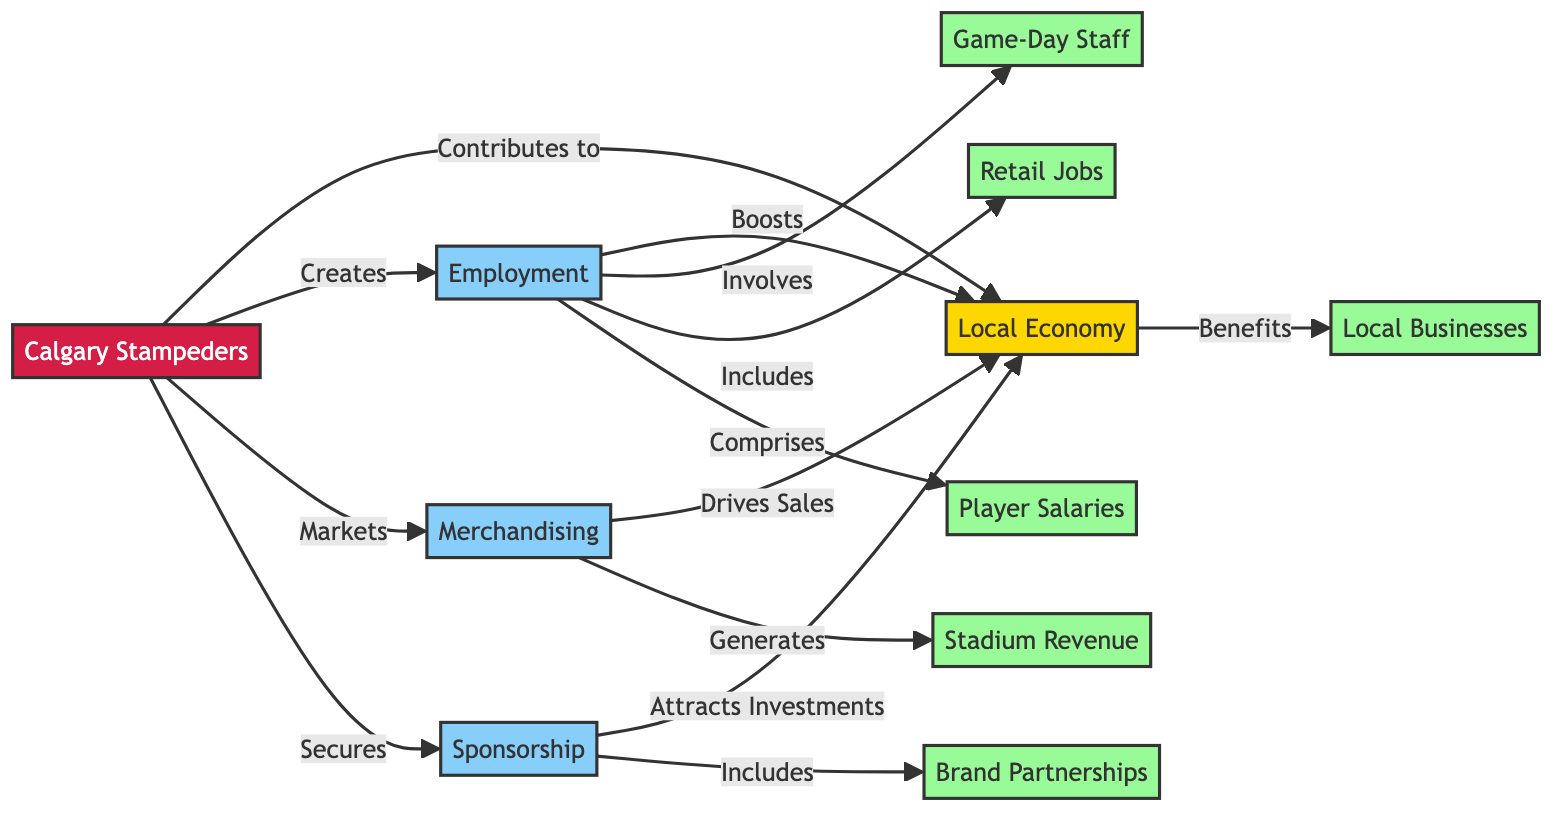What is the main contribution of the Calgary Stampeders to the local economy? The diagram indicates that the main contribution of the Calgary Stampeders to the local economy is through employment, merchandising, and sponsorship. These categories represent the primary ways they bolster the local economy.
Answer: Employment, Merchandising, and Sponsorship How many categories are shown in the diagram? The diagram displays three main categories, which are Employment, Merchandising, and Sponsorship. To arrive at this answer, we can simply count the number of distinct category nodes displayed.
Answer: 3 Which category includes game-day staff? The category that includes game-day staff is Employment. According to the diagram, Employment specifically mentions game-day staff as one of its subcategories.
Answer: Employment What do merchandising efforts drive in the local economy? According to the diagram, merchandising efforts drive sales in the local economy. This is captured by the connection between the Merchandising category and its impact on the local economy node.
Answer: Sales How does the Calgary Stampeders contribute to employment? The Calgary Stampeders contribute to employment by creating jobs, which includes game-day staff positions and retail jobs in the local area. The relationship is made clear in the diagram by the connection of Employment to the team and its associated subcategories.
Answer: Creating jobs Which category attracts investments? The category that attracts investments is Sponsorship. The diagram shows a direct path from the Sponsorship category to its impact on the local economy, highlighting its role in attracting financial backing.
Answer: Sponsorship How many subcategories are related to Employment? There are two subcategories related to Employment: game-day staff and retail jobs. This can be verified by counting the subcategories directly connected to the Employment category in the diagram.
Answer: 2 What does sponsorship involve? Sponsorship involves brand partnerships, as indicated on the diagram. It explicitly states that brand partnerships are part of the Sponsorship category, illustrating its role in the local economy.
Answer: Brand Partnerships What benefits do local businesses receive? Local businesses benefit from the Calgary Stampeders through stadium revenue and increased foot traffic, which is represented by the connection from the local economy node back to local businesses in the diagram.
Answer: Stadium Revenue and Increased Foot Traffic 